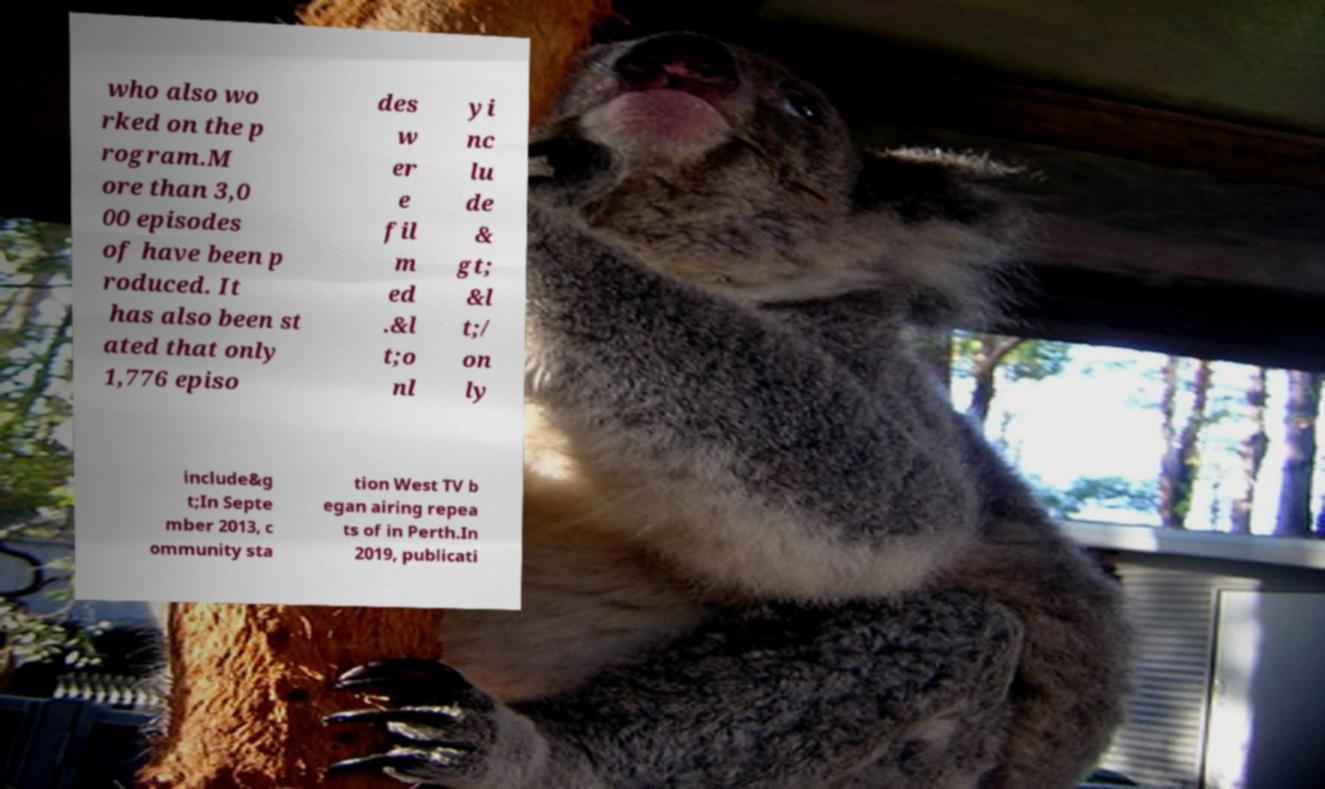For documentation purposes, I need the text within this image transcribed. Could you provide that? who also wo rked on the p rogram.M ore than 3,0 00 episodes of have been p roduced. It has also been st ated that only 1,776 episo des w er e fil m ed .&l t;o nl yi nc lu de & gt; &l t;/ on ly include&g t;In Septe mber 2013, c ommunity sta tion West TV b egan airing repea ts of in Perth.In 2019, publicati 